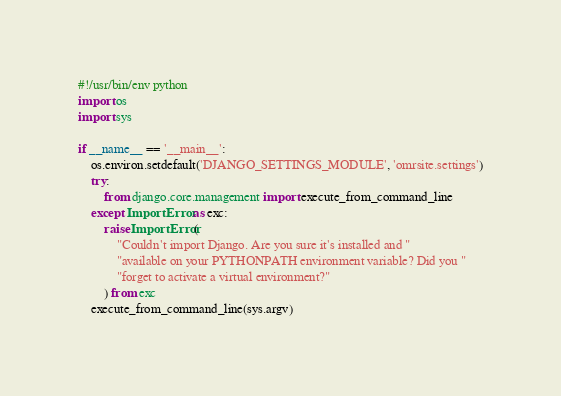Convert code to text. <code><loc_0><loc_0><loc_500><loc_500><_Python_>#!/usr/bin/env python
import os
import sys

if __name__ == '__main__':
    os.environ.setdefault('DJANGO_SETTINGS_MODULE', 'omrsite.settings')
    try:
        from django.core.management import execute_from_command_line
    except ImportError as exc:
        raise ImportError(
            "Couldn't import Django. Are you sure it's installed and "
            "available on your PYTHONPATH environment variable? Did you "
            "forget to activate a virtual environment?"
        ) from exc
    execute_from_command_line(sys.argv)
</code> 